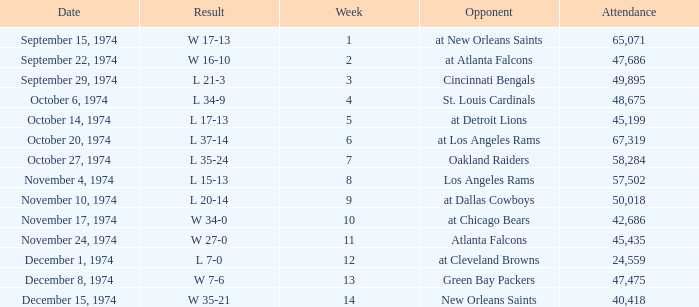Which week was the game played on December 8, 1974? 13.0. 